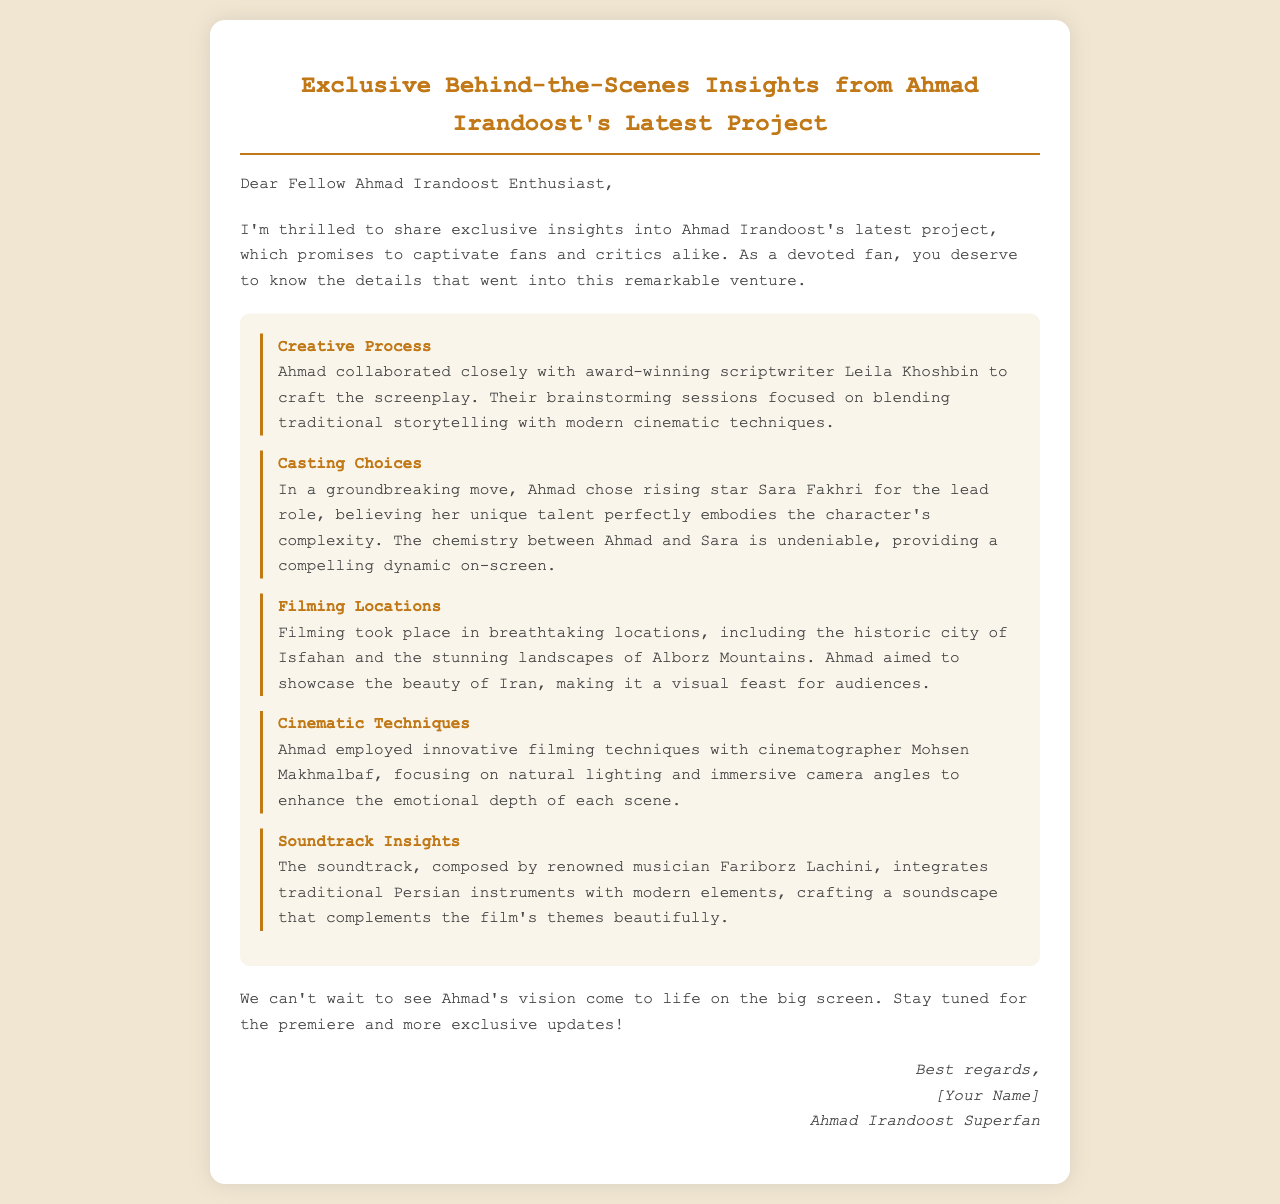what was the collaboration for the screenplay? Ahmad collaborated closely with award-winning scriptwriter Leila Khoshbin to craft the screenplay.
Answer: Leila Khoshbin who plays the lead role in the project? In a groundbreaking move, Ahmad chose rising star Sara Fakhri for the lead role.
Answer: Sara Fakhri which locations were used for filming? Filming took place in breathtaking locations, including the historic city of Isfahan and the stunning landscapes of Alborz Mountains.
Answer: Isfahan and Alborz Mountains who worked as the cinematographer? Ahmad employed innovative filming techniques with cinematographer Mohsen Makhmalbaf.
Answer: Mohsen Makhmalbaf what type of instruments are used in the soundtrack? The soundtrack, composed by renowned musician Fariborz Lachini, integrates traditional Persian instruments with modern elements.
Answer: traditional Persian instruments what is the purpose of Ahmad's creative process? Their brainstorming sessions focused on blending traditional storytelling with modern cinematic techniques.
Answer: blending traditional storytelling with modern cinematic techniques what is the tone of the closing message? The closing message expresses anticipation and excitement for Ahmad's vision.
Answer: anticipation and excitement what is the email's intended audience? The email is addressed to fellow fans of Ahmad Irandoost, indicating it's meant for a specific group of enthusiasts.
Answer: fellow Ahmad Irandoost Enthusiast 